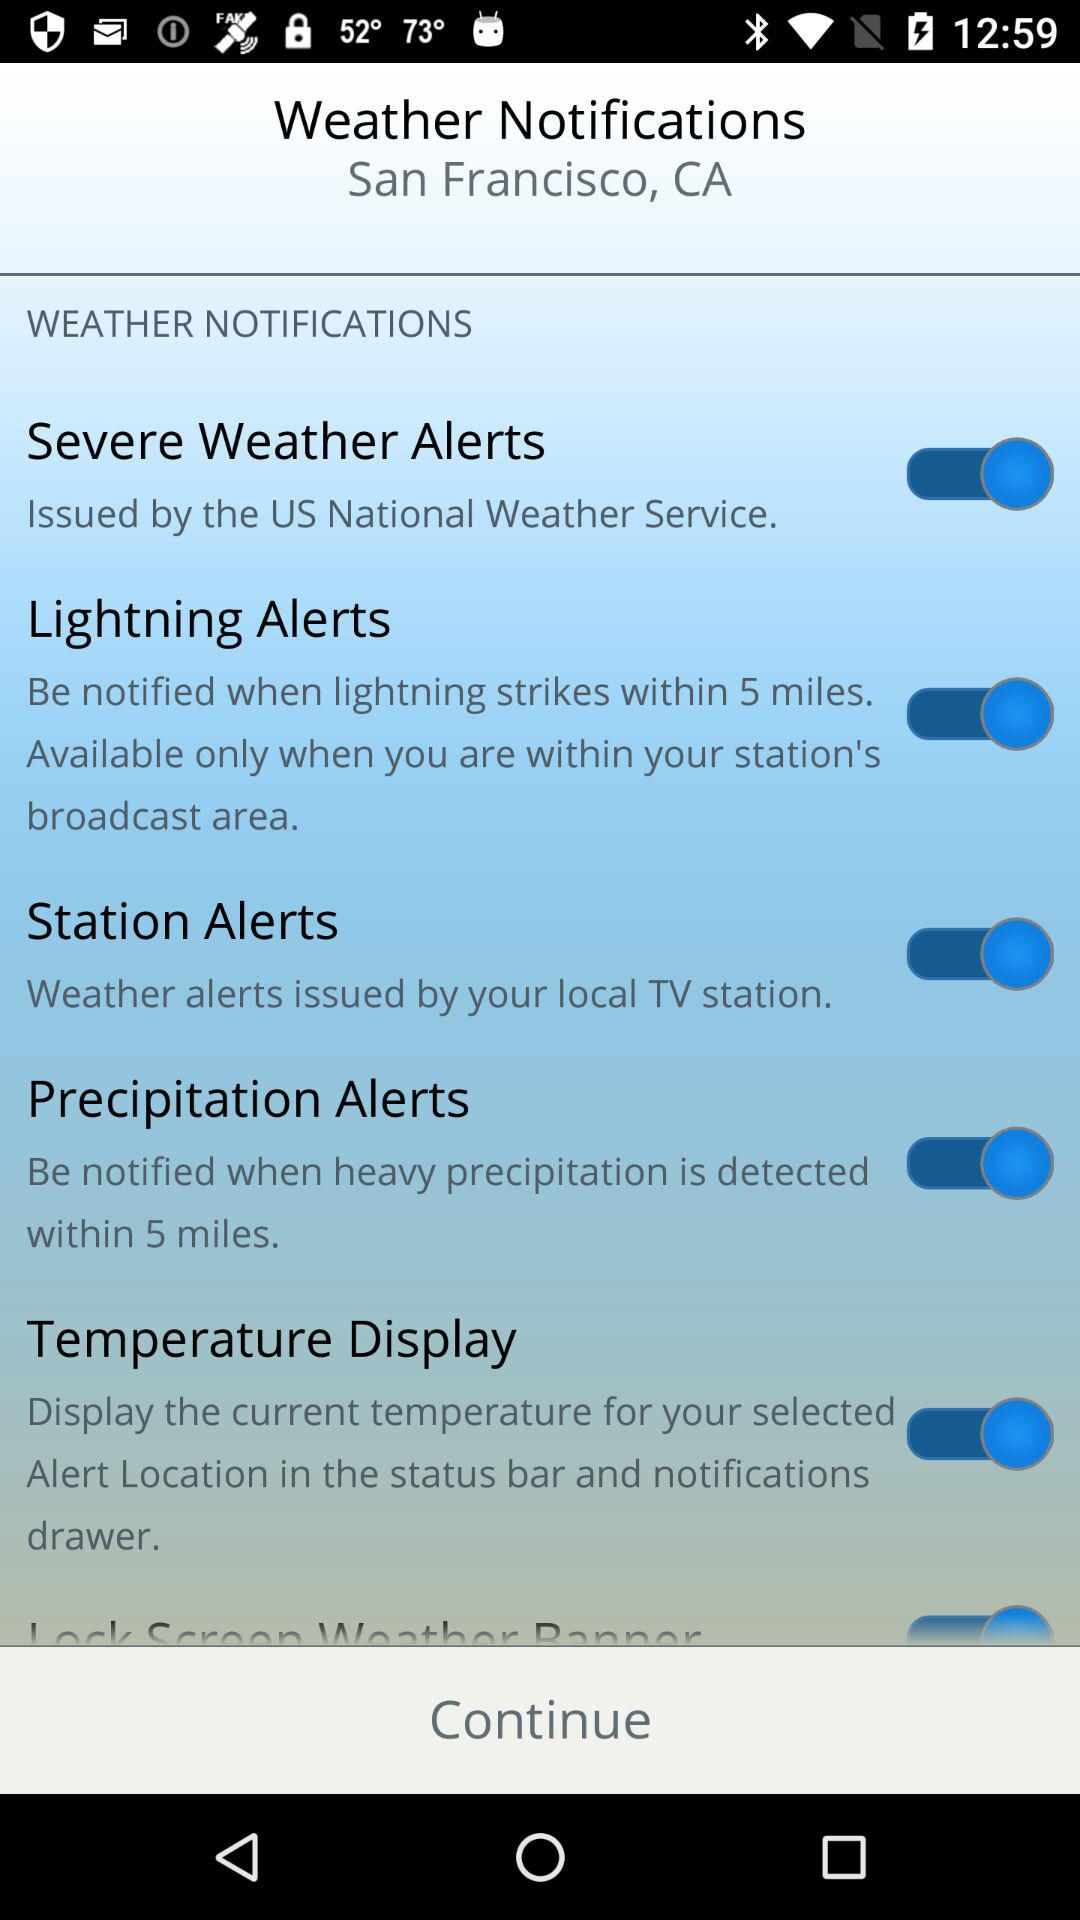What is the status of "Severe Weather Alerts"? The status is "on". 